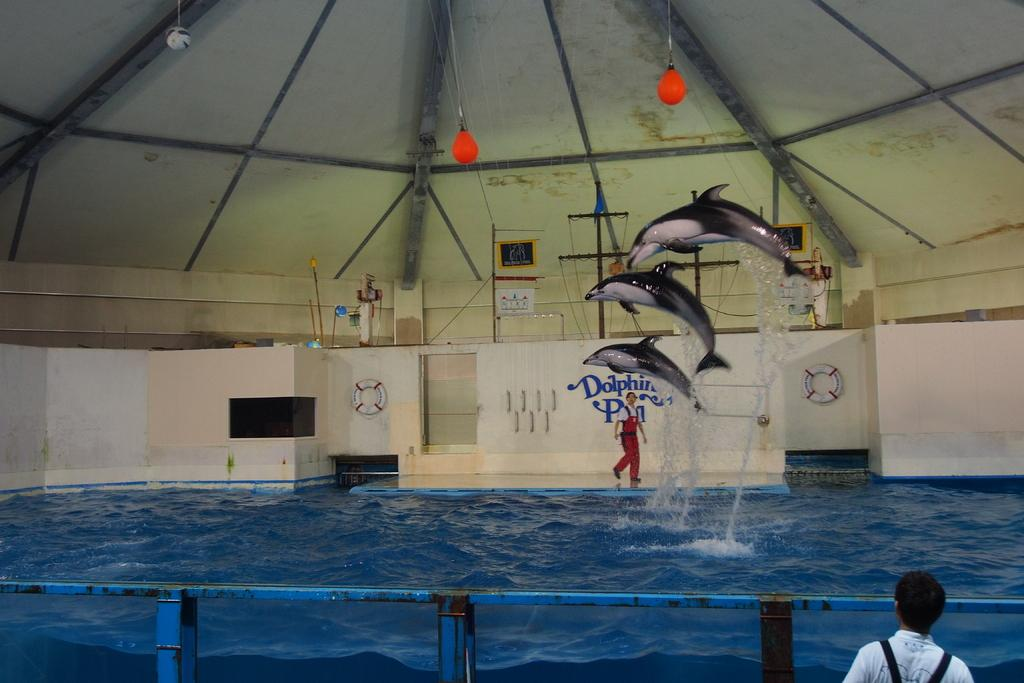What is happening in the image? There is a dolphin show in the image. What objects are related to the dolphin show? Swimming tubes are visible in the image. What type of structure can be seen in the image? There is a shed in the image. Where is the dolphin show taking place? A swimming pool is present in the image. What are the iron poles used for in the image? Iron poles are in the image, possibly for supporting structures or equipment. How many people are in the image? There are persons in the image. What type of government is depicted in the image? There is no depiction of a government in the image; it features a dolphin show and related elements. Can you tell me how many women are in the image? The provided facts do not specify the gender of the persons in the image, so it is impossible to determine the number of women. 